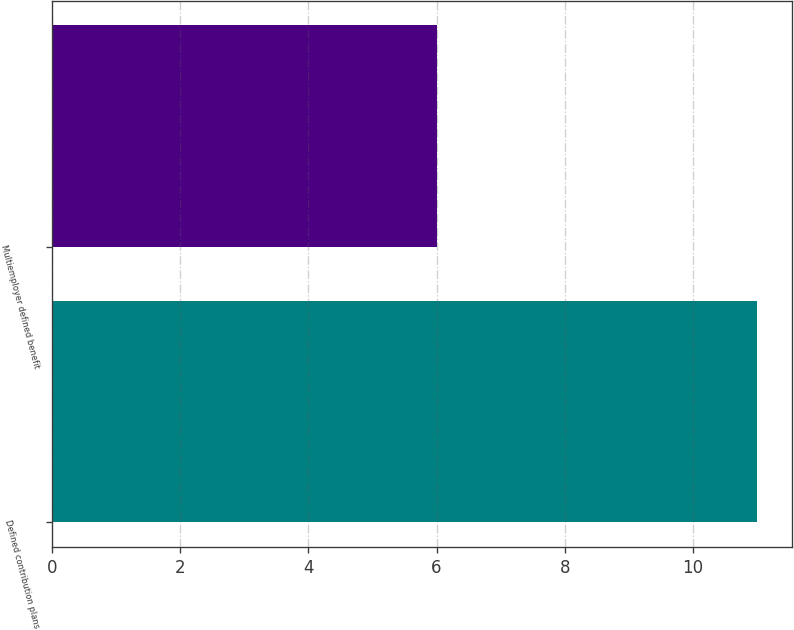Convert chart to OTSL. <chart><loc_0><loc_0><loc_500><loc_500><bar_chart><fcel>Defined contribution plans<fcel>Multiemployer defined benefit<nl><fcel>11<fcel>6<nl></chart> 